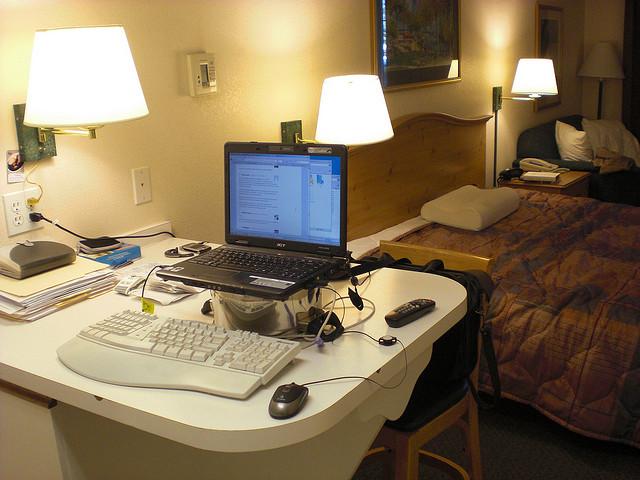Is the laptop turned on?
Answer briefly. Yes. What kind of room is this?
Answer briefly. Hotel. Why are there two keyboards?
Be succinct. Yes. 